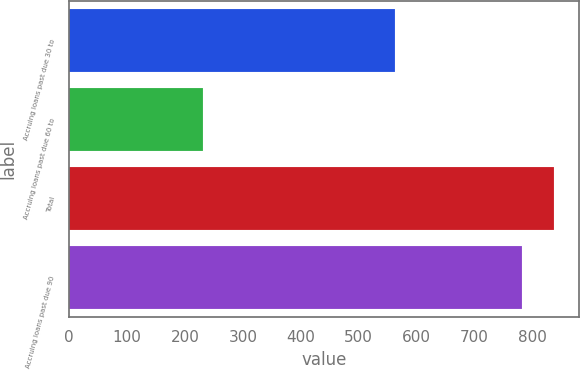Convert chart. <chart><loc_0><loc_0><loc_500><loc_500><bar_chart><fcel>Accruing loans past due 30 to<fcel>Accruing loans past due 60 to<fcel>Total<fcel>Accruing loans past due 90<nl><fcel>562<fcel>232<fcel>838.2<fcel>782<nl></chart> 